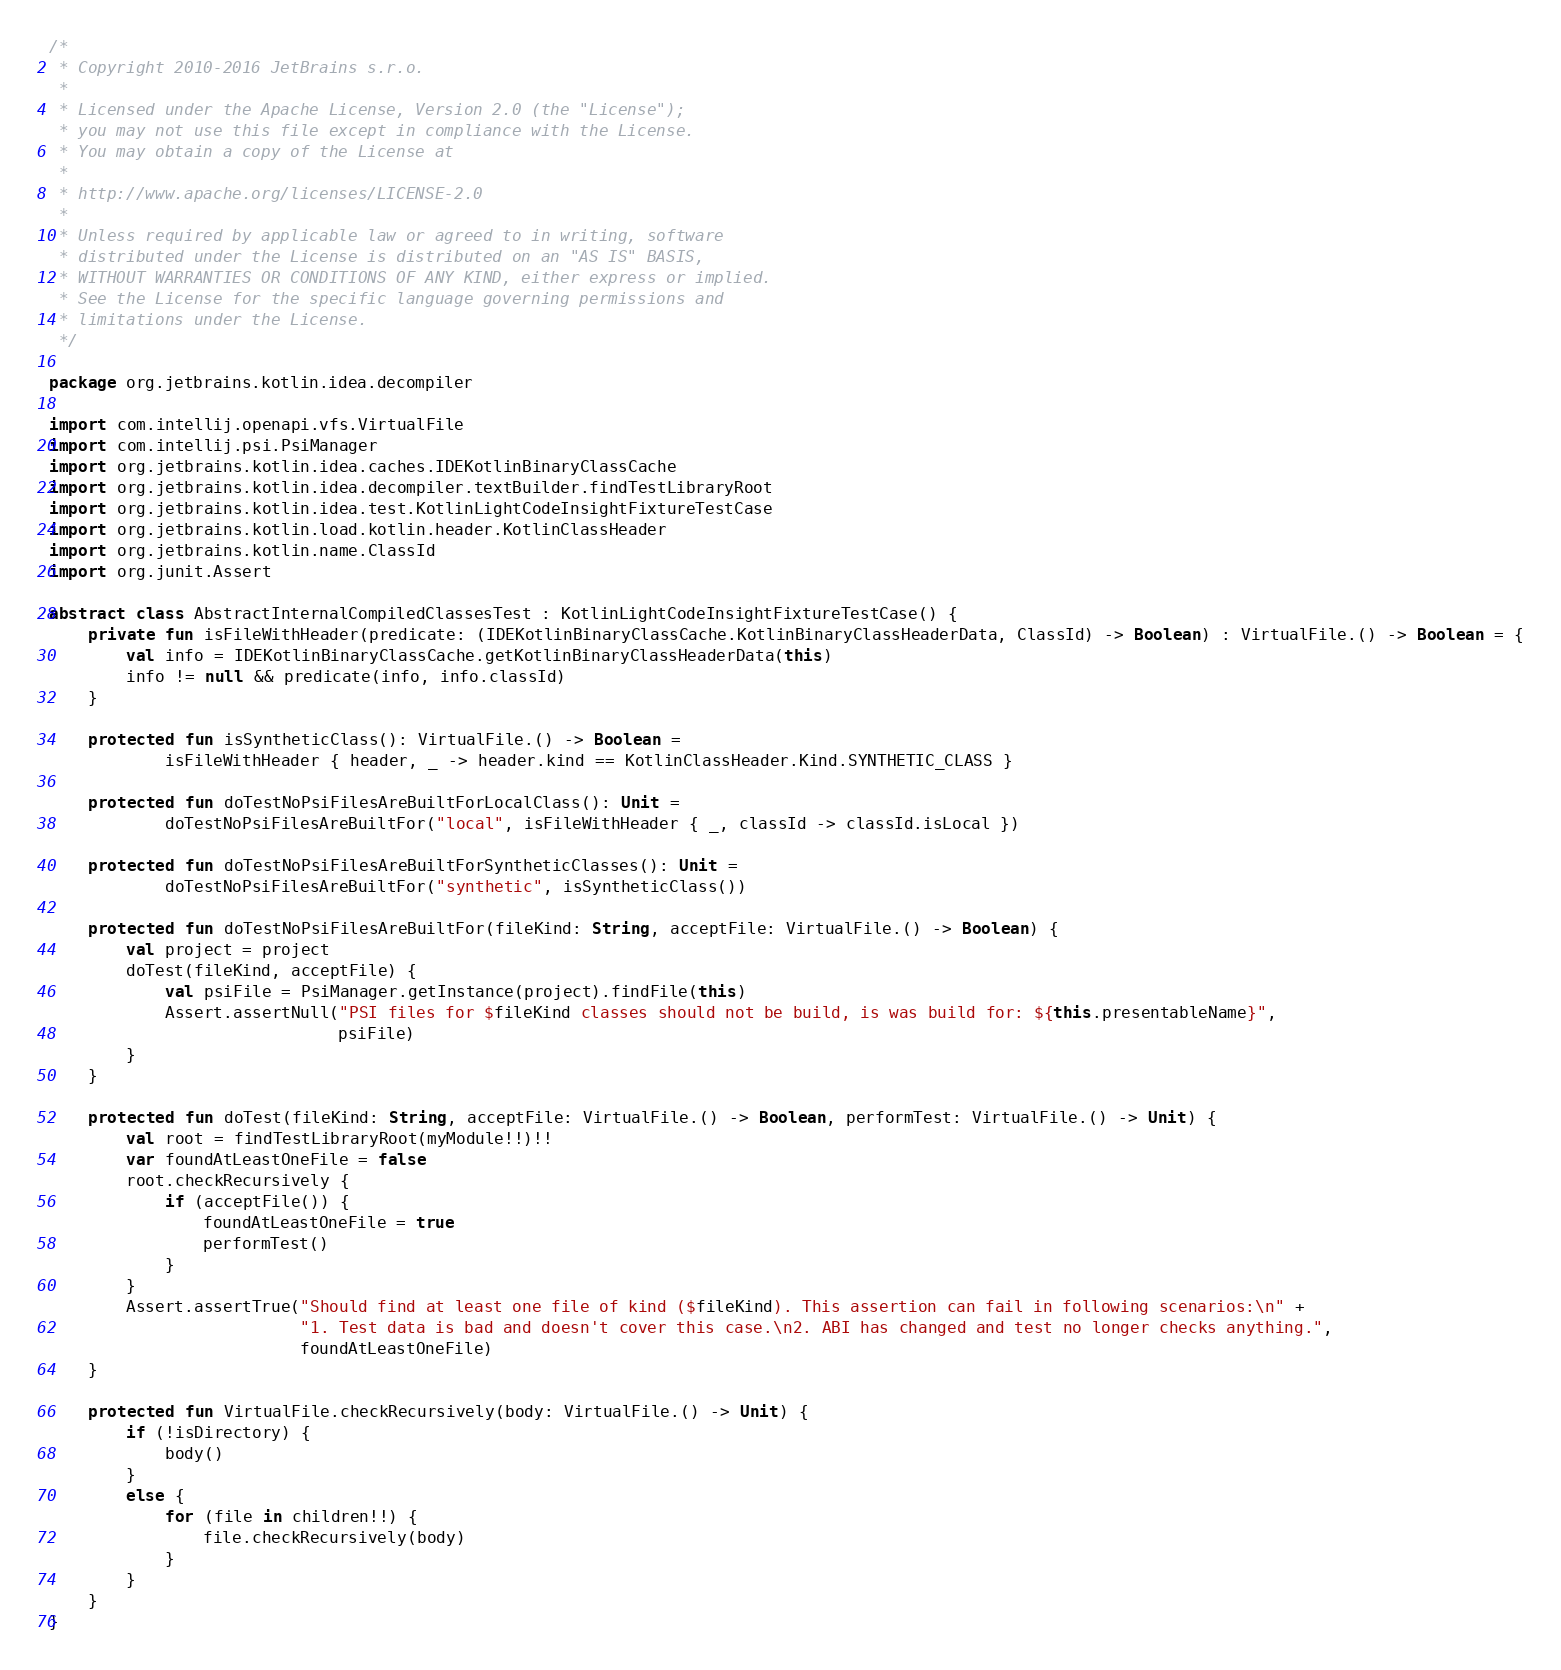Convert code to text. <code><loc_0><loc_0><loc_500><loc_500><_Kotlin_>/*
 * Copyright 2010-2016 JetBrains s.r.o.
 *
 * Licensed under the Apache License, Version 2.0 (the "License");
 * you may not use this file except in compliance with the License.
 * You may obtain a copy of the License at
 *
 * http://www.apache.org/licenses/LICENSE-2.0
 *
 * Unless required by applicable law or agreed to in writing, software
 * distributed under the License is distributed on an "AS IS" BASIS,
 * WITHOUT WARRANTIES OR CONDITIONS OF ANY KIND, either express or implied.
 * See the License for the specific language governing permissions and
 * limitations under the License.
 */

package org.jetbrains.kotlin.idea.decompiler

import com.intellij.openapi.vfs.VirtualFile
import com.intellij.psi.PsiManager
import org.jetbrains.kotlin.idea.caches.IDEKotlinBinaryClassCache
import org.jetbrains.kotlin.idea.decompiler.textBuilder.findTestLibraryRoot
import org.jetbrains.kotlin.idea.test.KotlinLightCodeInsightFixtureTestCase
import org.jetbrains.kotlin.load.kotlin.header.KotlinClassHeader
import org.jetbrains.kotlin.name.ClassId
import org.junit.Assert

abstract class AbstractInternalCompiledClassesTest : KotlinLightCodeInsightFixtureTestCase() {
    private fun isFileWithHeader(predicate: (IDEKotlinBinaryClassCache.KotlinBinaryClassHeaderData, ClassId) -> Boolean) : VirtualFile.() -> Boolean = {
        val info = IDEKotlinBinaryClassCache.getKotlinBinaryClassHeaderData(this)
        info != null && predicate(info, info.classId)
    }

    protected fun isSyntheticClass(): VirtualFile.() -> Boolean =
            isFileWithHeader { header, _ -> header.kind == KotlinClassHeader.Kind.SYNTHETIC_CLASS }

    protected fun doTestNoPsiFilesAreBuiltForLocalClass(): Unit =
            doTestNoPsiFilesAreBuiltFor("local", isFileWithHeader { _, classId -> classId.isLocal })

    protected fun doTestNoPsiFilesAreBuiltForSyntheticClasses(): Unit =
            doTestNoPsiFilesAreBuiltFor("synthetic", isSyntheticClass())

    protected fun doTestNoPsiFilesAreBuiltFor(fileKind: String, acceptFile: VirtualFile.() -> Boolean) {
        val project = project
        doTest(fileKind, acceptFile) {
            val psiFile = PsiManager.getInstance(project).findFile(this)
            Assert.assertNull("PSI files for $fileKind classes should not be build, is was build for: ${this.presentableName}",
                              psiFile)
        }
    }

    protected fun doTest(fileKind: String, acceptFile: VirtualFile.() -> Boolean, performTest: VirtualFile.() -> Unit) {
        val root = findTestLibraryRoot(myModule!!)!!
        var foundAtLeastOneFile = false
        root.checkRecursively {
            if (acceptFile()) {
                foundAtLeastOneFile = true
                performTest()
            }
        }
        Assert.assertTrue("Should find at least one file of kind ($fileKind). This assertion can fail in following scenarios:\n" +
                          "1. Test data is bad and doesn't cover this case.\n2. ABI has changed and test no longer checks anything.",
                          foundAtLeastOneFile)
    }

    protected fun VirtualFile.checkRecursively(body: VirtualFile.() -> Unit) {
        if (!isDirectory) {
            body()
        }
        else {
            for (file in children!!) {
                file.checkRecursively(body)
            }
        }
    }
}

</code> 